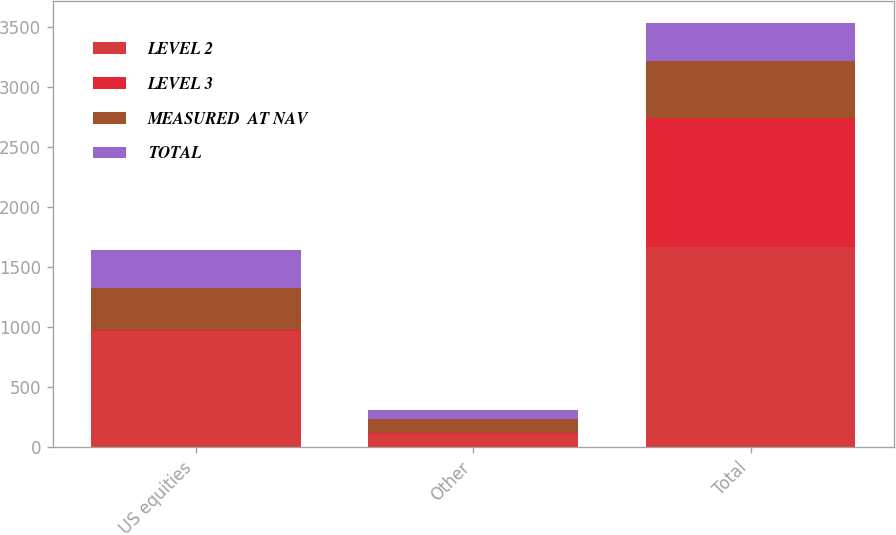Convert chart to OTSL. <chart><loc_0><loc_0><loc_500><loc_500><stacked_bar_chart><ecel><fcel>US equities<fcel>Other<fcel>Total<nl><fcel>LEVEL 2<fcel>968<fcel>107<fcel>1670<nl><fcel>LEVEL 3<fcel>5<fcel>6<fcel>1078<nl><fcel>MEASURED  AT NAV<fcel>350<fcel>121<fcel>471<nl><fcel>TOTAL<fcel>320<fcel>78<fcel>320<nl></chart> 